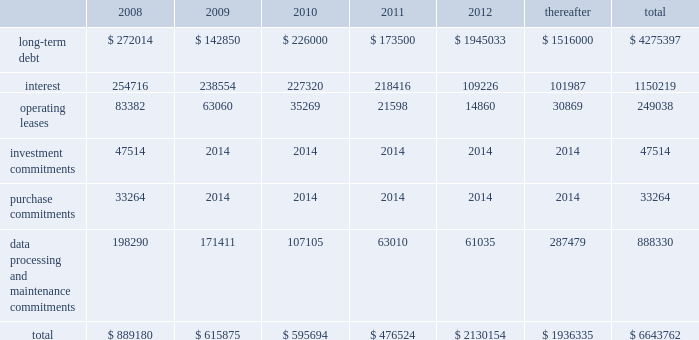Our existing cash flow hedges are highly effective and there is no current impact on earnings due to hedge ineffectiveness .
It is our policy to execute such instruments with credit-worthy banks and not to enter into derivative financial instruments for speculative purposes .
Contractual obligations fis 2019s long-term contractual obligations generally include its long-term debt and operating lease payments on certain of its property and equipment .
The table summarizes fis 2019s significant contractual obligations and commitments as of december 31 , 2007 ( in thousands ) : .
Off-balance sheet arrangements fis does not have any material off-balance sheet arrangements other than operating leases .
Escrow arrangements in conducting our title agency , closing and 1031 exchange services operations , we routinely hold customers 2019 assets in escrow , pending completion of real estate transactions .
Certain of these amounts are maintained in segregated bank accounts and have not been included in the accompanying consolidated balance sheets .
We have a contingent liability relating to proper disposition of these balances , which amounted to $ 1926.8 million at december 31 , 2007 .
As a result of holding these customers 2019 assets in escrow , we have ongoing programs for realizing economic benefits during the year through favorable borrowing and vendor arrangements with various banks .
There were no loans outstanding as of december 31 , 2007 and these balances were invested in short term , high grade investments that minimize the risk to principal .
Recent accounting pronouncements in december 2007 , the fasb issued sfas no .
141 ( revised 2007 ) , business combinations ( 201csfas 141 ( r ) 201d ) , requiring an acquirer in a business combination to recognize the assets acquired , the liabilities assumed , and any noncontrolling interest in the acquiree at their fair values at the acquisition date , with limited exceptions .
The costs of the acquisition and any related restructuring costs will be recognized separately .
Assets and liabilities arising from contingencies in a business combination are to be recognized at their fair value at the acquisition date and adjusted prospectively as new information becomes available .
When the fair value of assets acquired exceeds the fair value of consideration transferred plus any noncontrolling interest in the acquiree , the excess will be recognized as a gain .
Under sfas 141 ( r ) , all business combinations will be accounted for by applying the acquisition method , including combinations among mutual entities and combinations by contract alone .
Sfas 141 ( r ) applies prospectively to business combinations for which the acquisition date is on or after the first annual reporting period beginning on or after december 15 , 2008 , is effective for periods beginning on or after december 15 , 2008 , and will apply to business combinations occurring after the effective date .
Management is currently evaluating the impact of this statement on our statements of financial position and operations .
In december 2007 , the fasb issued sfas no .
160 , noncontrolling interests in consolidated financial statements 2014 an amendment of arb no .
51 ( 201csfas 160 201d ) , requiring noncontrolling interests ( sometimes called minority interests ) to be presented as a component of equity on the balance sheet .
Sfas 160 also requires that the amount of net income attributable to the parent and to the noncontrolling interests be clearly identified and presented on the face of the consolidated statement of income .
This statement eliminates the need to apply purchase .
What percentage of total significant contractual obligations and commitments as of december 31 , 2007 are due in 2009? 
Computations: (615875 / 6643762)
Answer: 0.0927. 